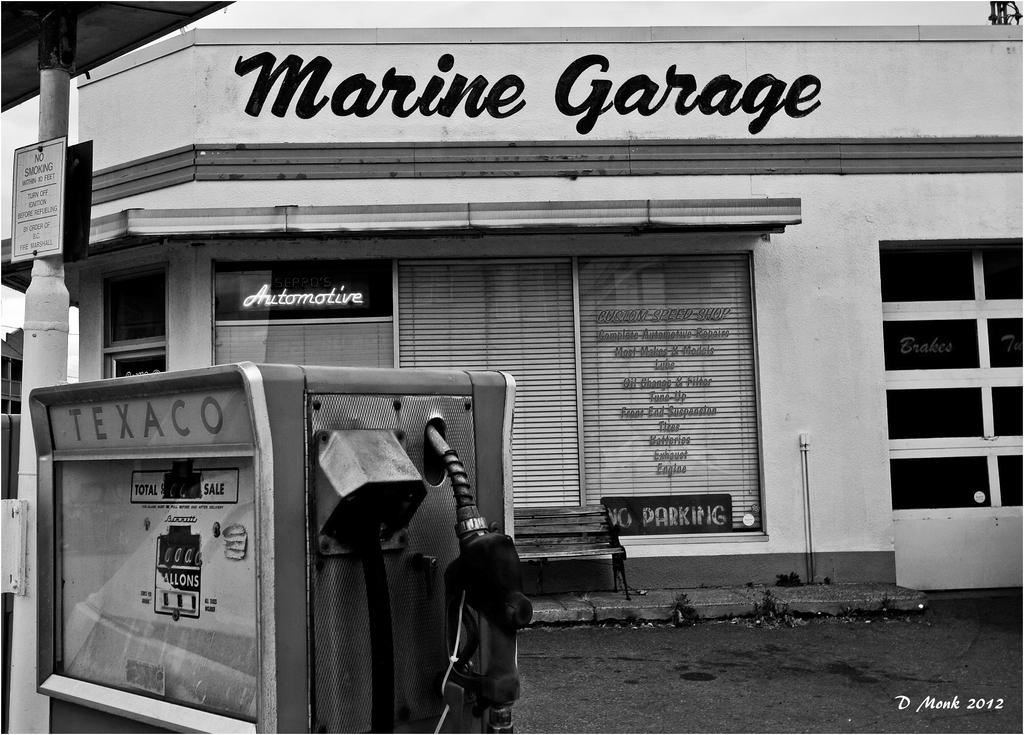What is the color scheme of the image? The image is black and white. What can be seen in the background of the image? There is a store in the background of the image. What piece of furniture is present in the image? There is a bench in the image. What object is located in the foreground of the image? There is a fuel filling machine in the foreground of the image. How many tickets are visible on the bench in the image? There are no tickets visible on the bench in the image. What addition can be made to the fuel filling machine to make it more efficient? The provided facts do not mention any need for improvement or addition to the fuel filling machine, and the image does not show any additional components or suggestions for improvement. 